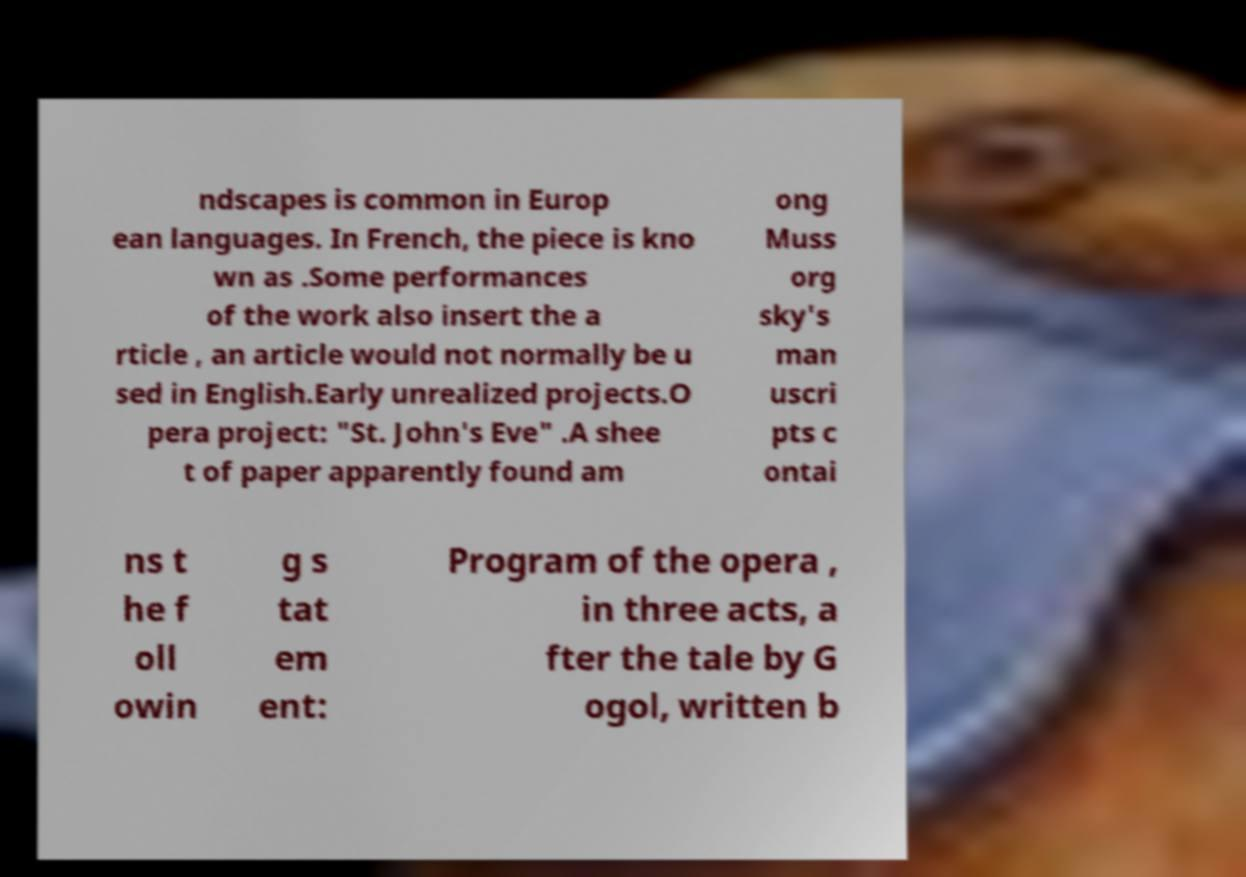Please identify and transcribe the text found in this image. ndscapes is common in Europ ean languages. In French, the piece is kno wn as .Some performances of the work also insert the a rticle , an article would not normally be u sed in English.Early unrealized projects.O pera project: "St. John's Eve" .A shee t of paper apparently found am ong Muss org sky's man uscri pts c ontai ns t he f oll owin g s tat em ent: Program of the opera , in three acts, a fter the tale by G ogol, written b 